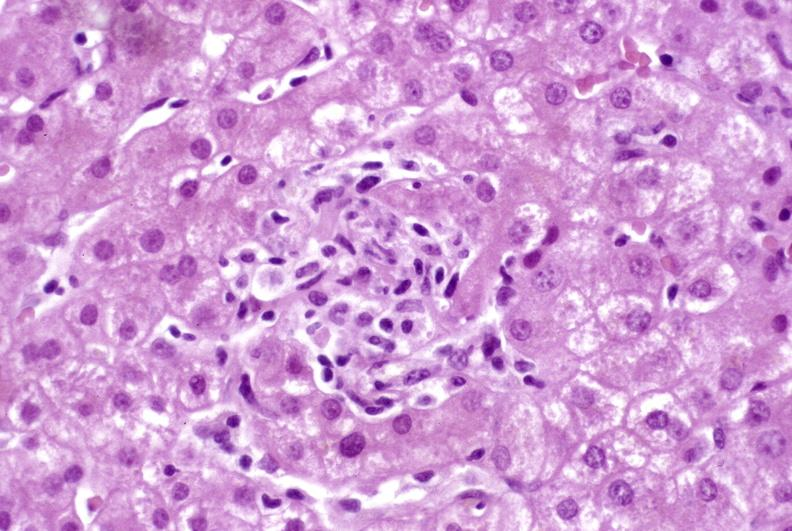s hepatobiliary present?
Answer the question using a single word or phrase. Yes 